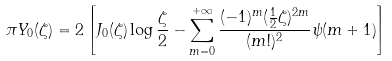<formula> <loc_0><loc_0><loc_500><loc_500>\pi Y _ { 0 } ( \zeta ) = 2 \left [ J _ { 0 } ( \zeta ) \log \frac { \zeta } { 2 } - \sum _ { m = 0 } ^ { + \infty } \frac { ( - 1 ) ^ { m } ( \frac { 1 } { 2 } \zeta ) ^ { 2 m } } { ( m ! ) ^ { 2 } } \psi ( m + 1 ) \right ]</formula> 